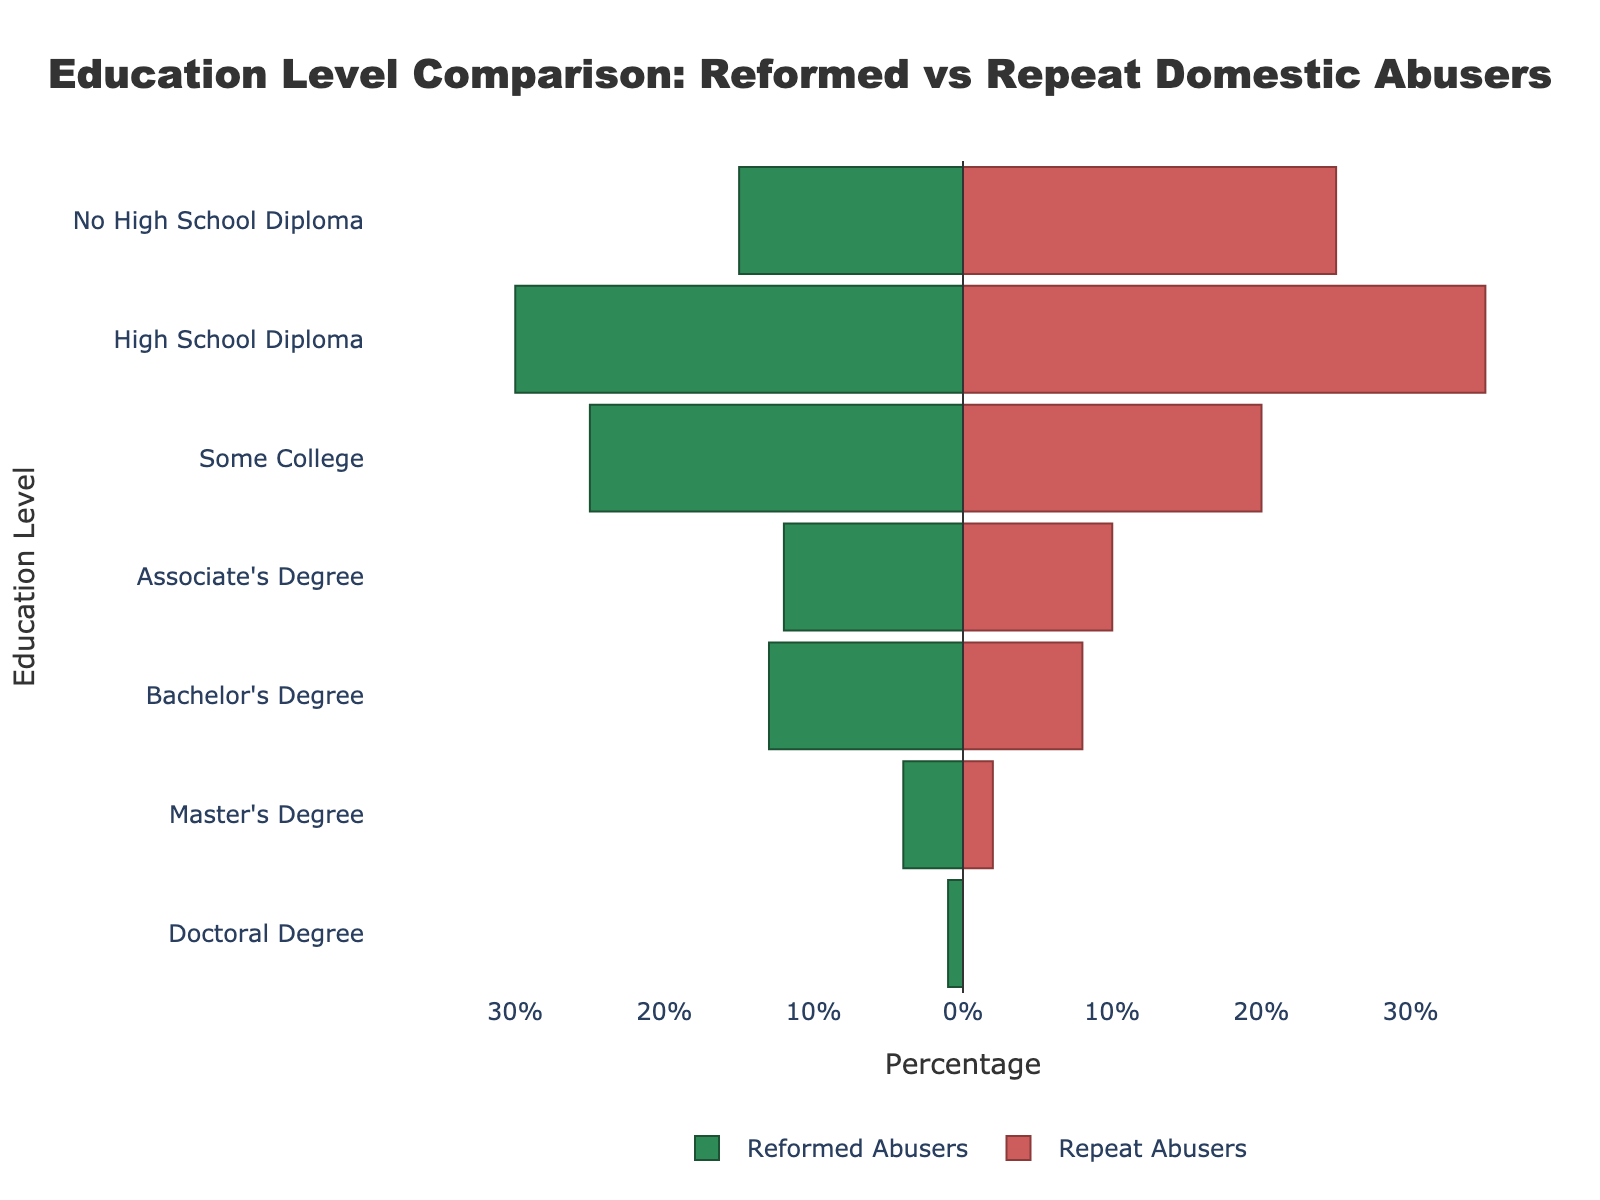What is the title of the figure? The title of the figure is usually located at the top and provides a summary of what the figure represents. In this case, it is "Education Level Comparison: Reformed vs Repeat Domestic Abusers".
Answer: Education Level Comparison: Reformed vs Repeat Domestic Abusers Which group has a higher percentage of individuals with a Doctoral Degree, reformed or repeat abusers? To answer this, compare the percentage values for the "Doctoral Degree" category for both groups. Reformed Abusers have 1%, whereas Repeat Abusers have 0%. Therefore, Reformed Abusers have a higher percentage.
Answer: Reformed Abusers How many distinct education levels are featured in the figure? Count the number of unique categories listed on the y-axis. The listed education levels are No High School Diploma, High School Diploma, Some College, Associate's Degree, Bachelor's Degree, Master's Degree, Doctoral Degree. There are 7 distinct education levels.
Answer: 7 Which education level shows the largest difference in percentage between reformed and repeat abusers? To determine this, calculate the absolute differences between percentages of reformed and repeat abusers for each education level: 10 (No High School Diploma), 5 (High School Diploma), 5 (Some College), 2 (Associate's Degree), 5 (Bachelor's Degree), 2 (Master's Degree), 1 (Doctoral Degree). The largest difference is 10 for No High School Diploma.
Answer: No High School Diploma What is the combined percentage of reformed abusers who have a Bachelor's Degree or higher? Sum the percentages for reformed abusers with Bachelor's Degree (13%), Master's Degree (4%) and Doctoral Degree (1%): 13 + 4 + 1 = 18.
Answer: 18 Which education level shows that repeat abusers have the lowest representation? Check the percentage values on the horizontal bar for repeat abusers across all education levels. The lowest value is 0% for Doctoral Degree.
Answer: Doctoral Degree Do reformed or repeat abusers more commonly have a High School Diploma? Compare the percentages for the "High School Diploma" category: reformed abusers have 30% and repeat abusers have 35%. Repeat abusers have a higher percentage.
Answer: Repeat Abusers What is the difference in percentage between reformed and repeat abusers with an Associate's Degree? Calculate the absolute difference: reformed abusers have 12% and repeat abusers have 10%. The difference is 12 - 10 = 2%.
Answer: 2 Among reformed abusers, which education level has the second-highest percentage? Look at the percentages for reformed abusers and identify the top two levels, starting with the highest: High School Diploma (30%), Some College (25%). The second highest is Some College.
Answer: Some College 